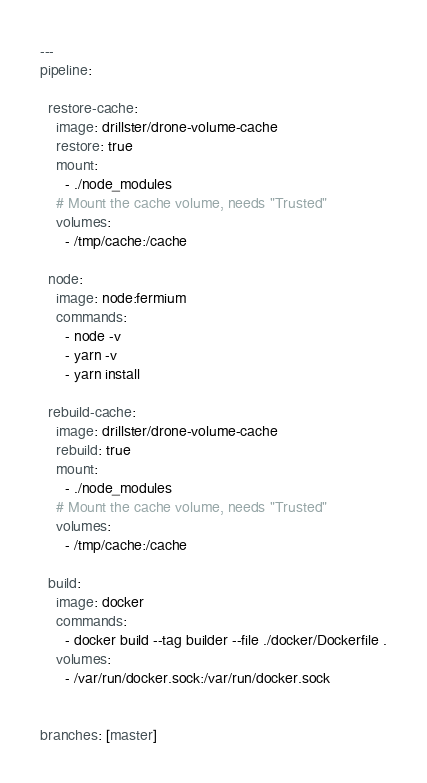Convert code to text. <code><loc_0><loc_0><loc_500><loc_500><_YAML_>---
pipeline:

  restore-cache:
    image: drillster/drone-volume-cache
    restore: true
    mount:
      - ./node_modules
    # Mount the cache volume, needs "Trusted"
    volumes:
      - /tmp/cache:/cache

  node:
    image: node:fermium
    commands:
      - node -v
      - yarn -v
      - yarn install

  rebuild-cache:
    image: drillster/drone-volume-cache
    rebuild: true
    mount:
      - ./node_modules
    # Mount the cache volume, needs "Trusted"
    volumes:
      - /tmp/cache:/cache

  build:
    image: docker
    commands:
      - docker build --tag builder --file ./docker/Dockerfile .
    volumes:
      - /var/run/docker.sock:/var/run/docker.sock


branches: [master]
</code> 